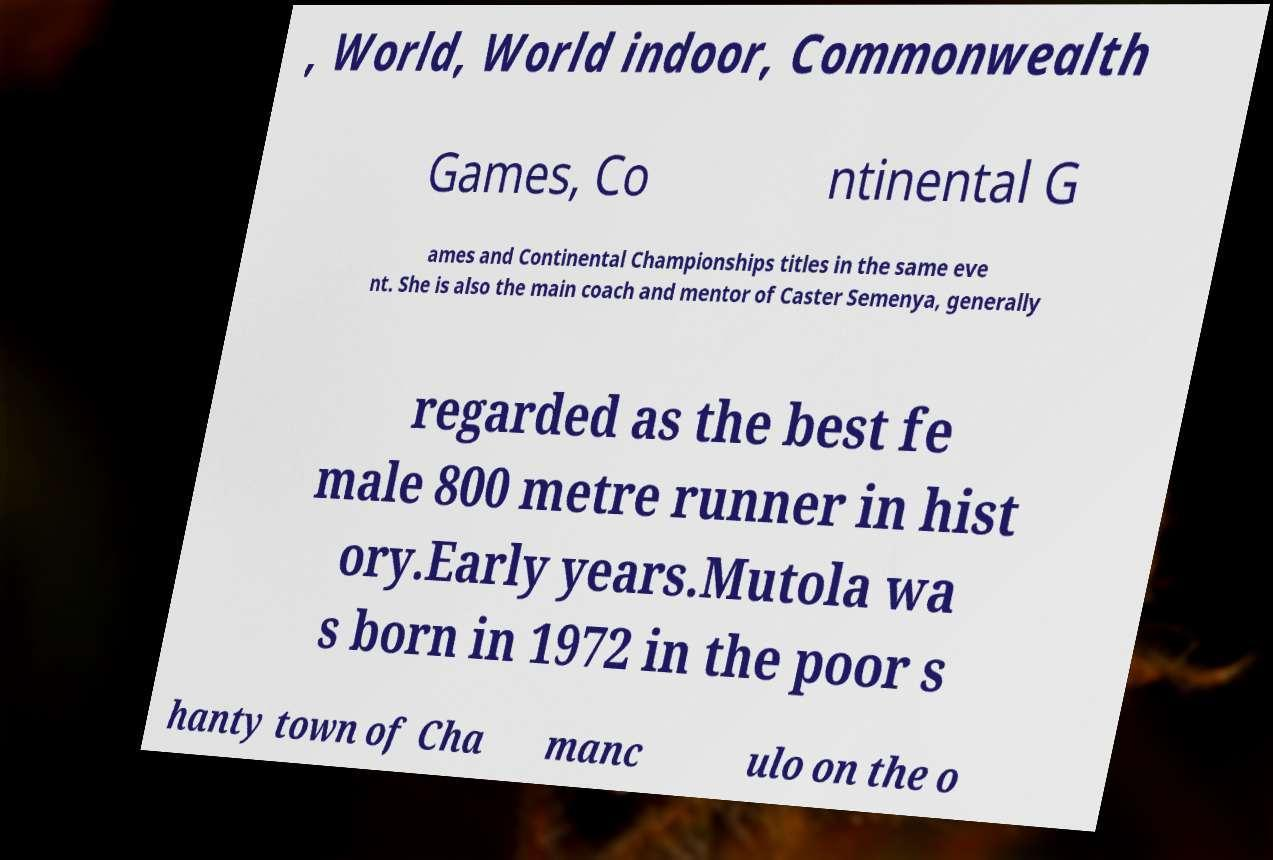Could you assist in decoding the text presented in this image and type it out clearly? , World, World indoor, Commonwealth Games, Co ntinental G ames and Continental Championships titles in the same eve nt. She is also the main coach and mentor of Caster Semenya, generally regarded as the best fe male 800 metre runner in hist ory.Early years.Mutola wa s born in 1972 in the poor s hanty town of Cha manc ulo on the o 